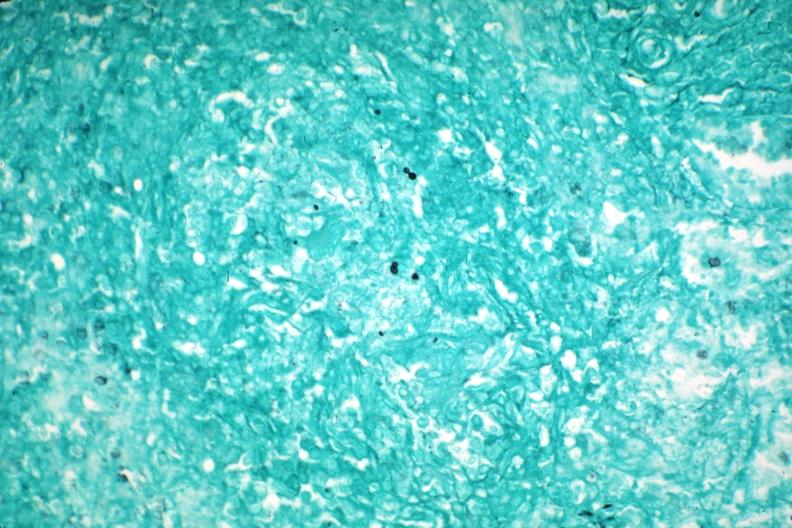what is present?
Answer the question using a single word or phrase. Spleen 